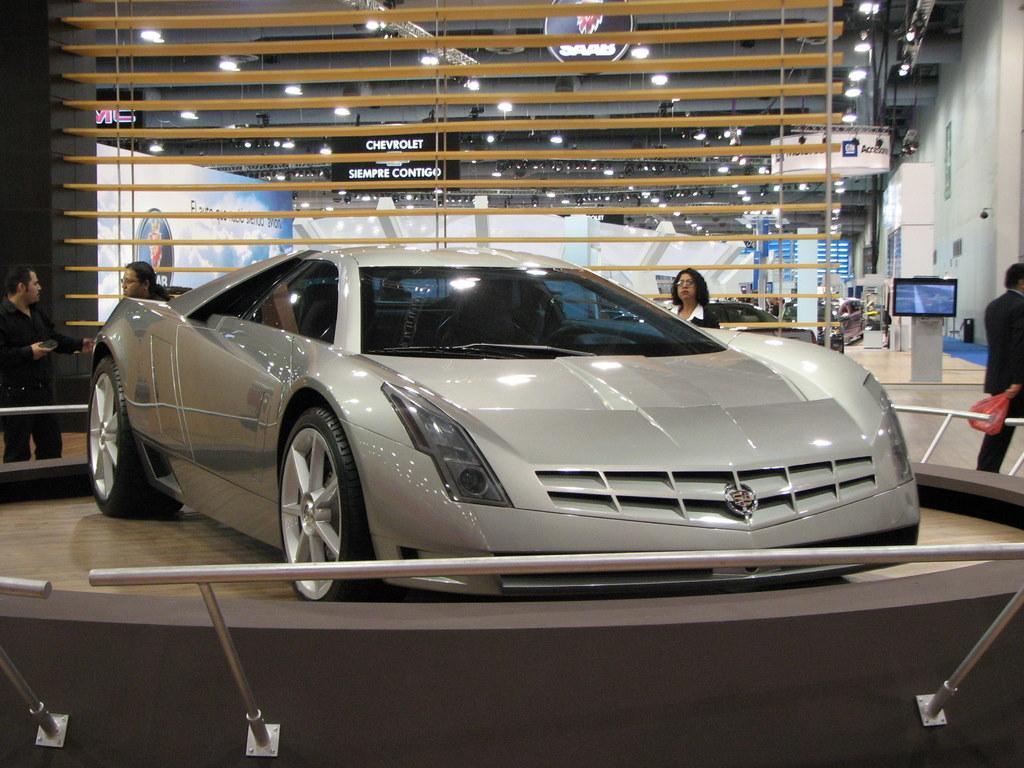Could you give a brief overview of what you see in this image? In this picture I can see the rods in front and I can see a white color car on the brown color surface. Behind the car I can see 4 persons. In the background I can see few boards, on which there is something written and I see the lights on the ceiling. On the right side of this picture I can see another car and I can also see a screen and I can see the walls. 